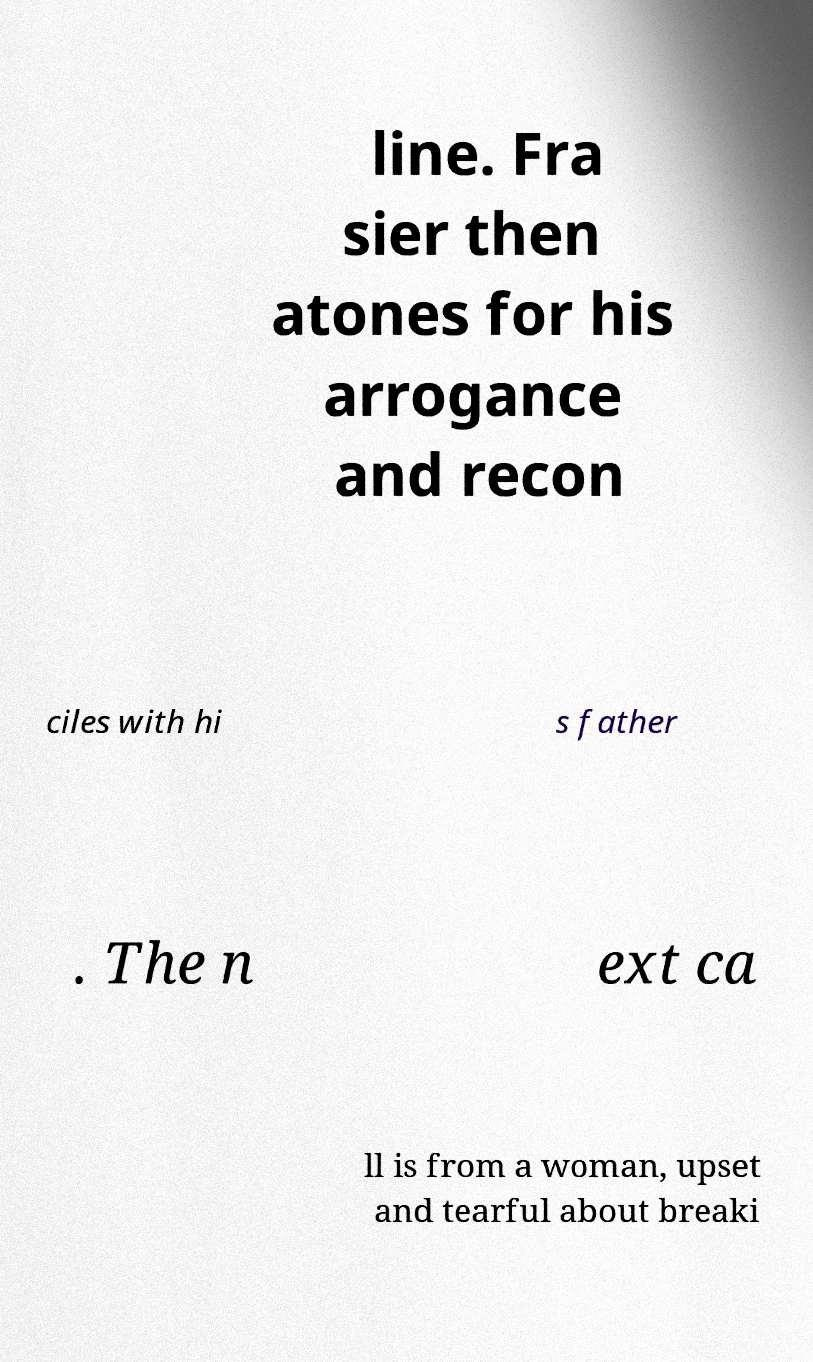Please identify and transcribe the text found in this image. line. Fra sier then atones for his arrogance and recon ciles with hi s father . The n ext ca ll is from a woman, upset and tearful about breaki 